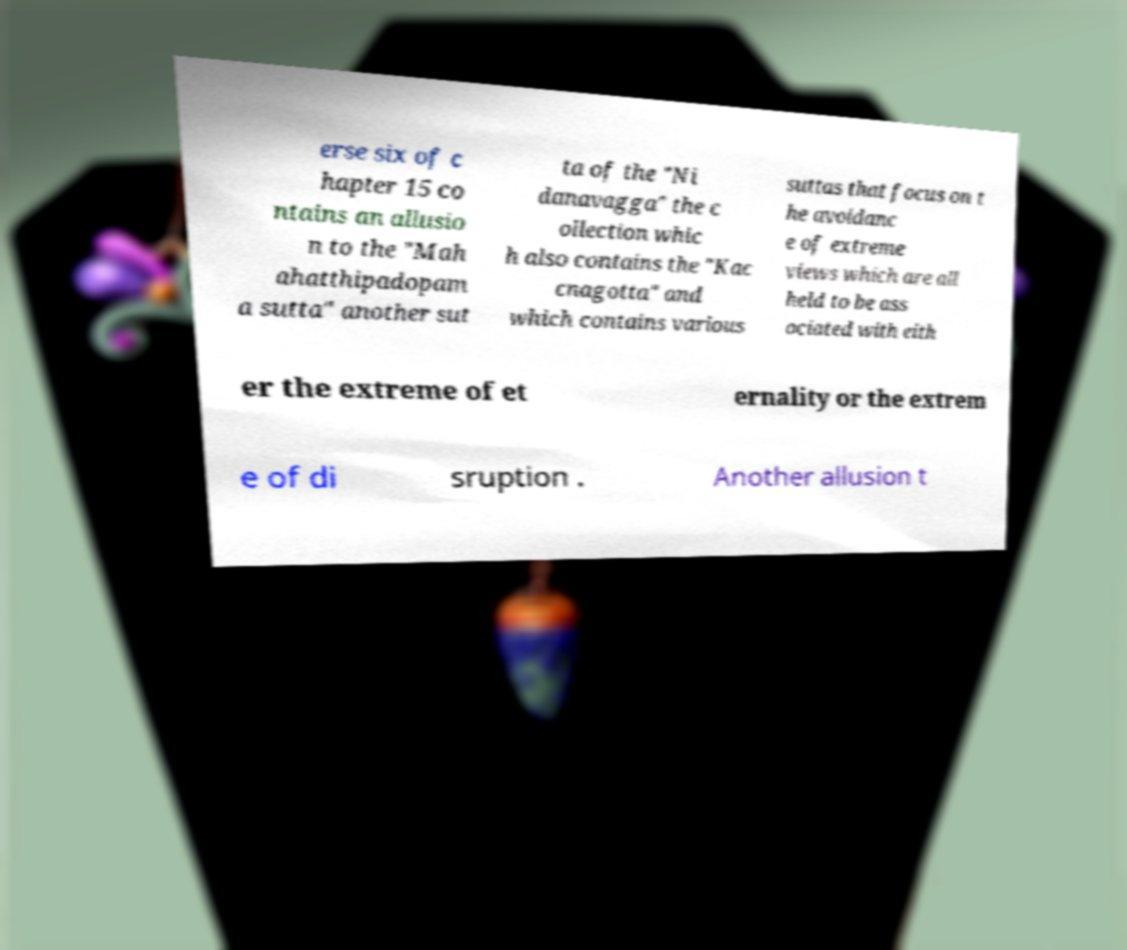Could you extract and type out the text from this image? erse six of c hapter 15 co ntains an allusio n to the "Mah ahatthipadopam a sutta" another sut ta of the "Ni danavagga" the c ollection whic h also contains the "Kac cnagotta" and which contains various suttas that focus on t he avoidanc e of extreme views which are all held to be ass ociated with eith er the extreme of et ernality or the extrem e of di sruption . Another allusion t 